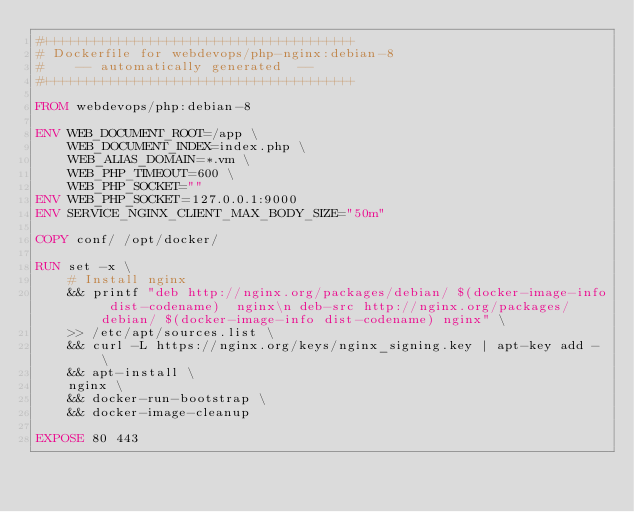<code> <loc_0><loc_0><loc_500><loc_500><_Dockerfile_>#+++++++++++++++++++++++++++++++++++++++
# Dockerfile for webdevops/php-nginx:debian-8
#    -- automatically generated  --
#+++++++++++++++++++++++++++++++++++++++

FROM webdevops/php:debian-8

ENV WEB_DOCUMENT_ROOT=/app \
    WEB_DOCUMENT_INDEX=index.php \
    WEB_ALIAS_DOMAIN=*.vm \
    WEB_PHP_TIMEOUT=600 \
    WEB_PHP_SOCKET=""
ENV WEB_PHP_SOCKET=127.0.0.1:9000
ENV SERVICE_NGINX_CLIENT_MAX_BODY_SIZE="50m"

COPY conf/ /opt/docker/

RUN set -x \
    # Install nginx
    && printf "deb http://nginx.org/packages/debian/ $(docker-image-info dist-codename)  nginx\n deb-src http://nginx.org/packages/debian/ $(docker-image-info dist-codename) nginx" \
    >> /etc/apt/sources.list \
    && curl -L https://nginx.org/keys/nginx_signing.key | apt-key add - \
    && apt-install \
    nginx \
    && docker-run-bootstrap \
    && docker-image-cleanup

EXPOSE 80 443
</code> 